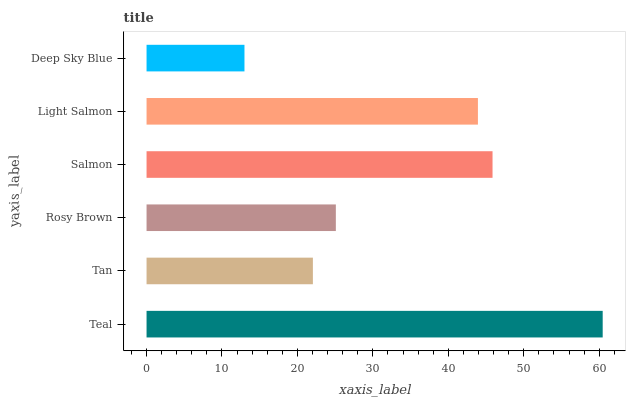Is Deep Sky Blue the minimum?
Answer yes or no. Yes. Is Teal the maximum?
Answer yes or no. Yes. Is Tan the minimum?
Answer yes or no. No. Is Tan the maximum?
Answer yes or no. No. Is Teal greater than Tan?
Answer yes or no. Yes. Is Tan less than Teal?
Answer yes or no. Yes. Is Tan greater than Teal?
Answer yes or no. No. Is Teal less than Tan?
Answer yes or no. No. Is Light Salmon the high median?
Answer yes or no. Yes. Is Rosy Brown the low median?
Answer yes or no. Yes. Is Salmon the high median?
Answer yes or no. No. Is Deep Sky Blue the low median?
Answer yes or no. No. 